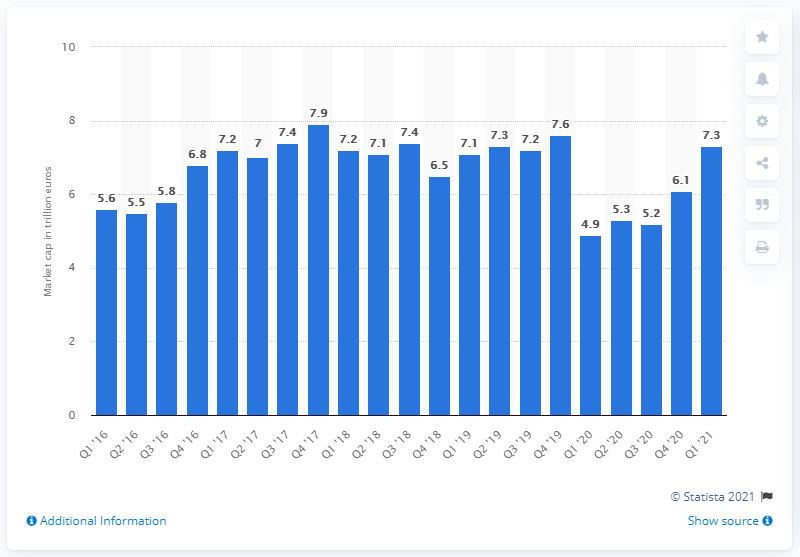Draw attention to some important aspects in this diagram. The market capitalization of the global banking sector in the first quarter of 2020 was $7.3 trillion. 